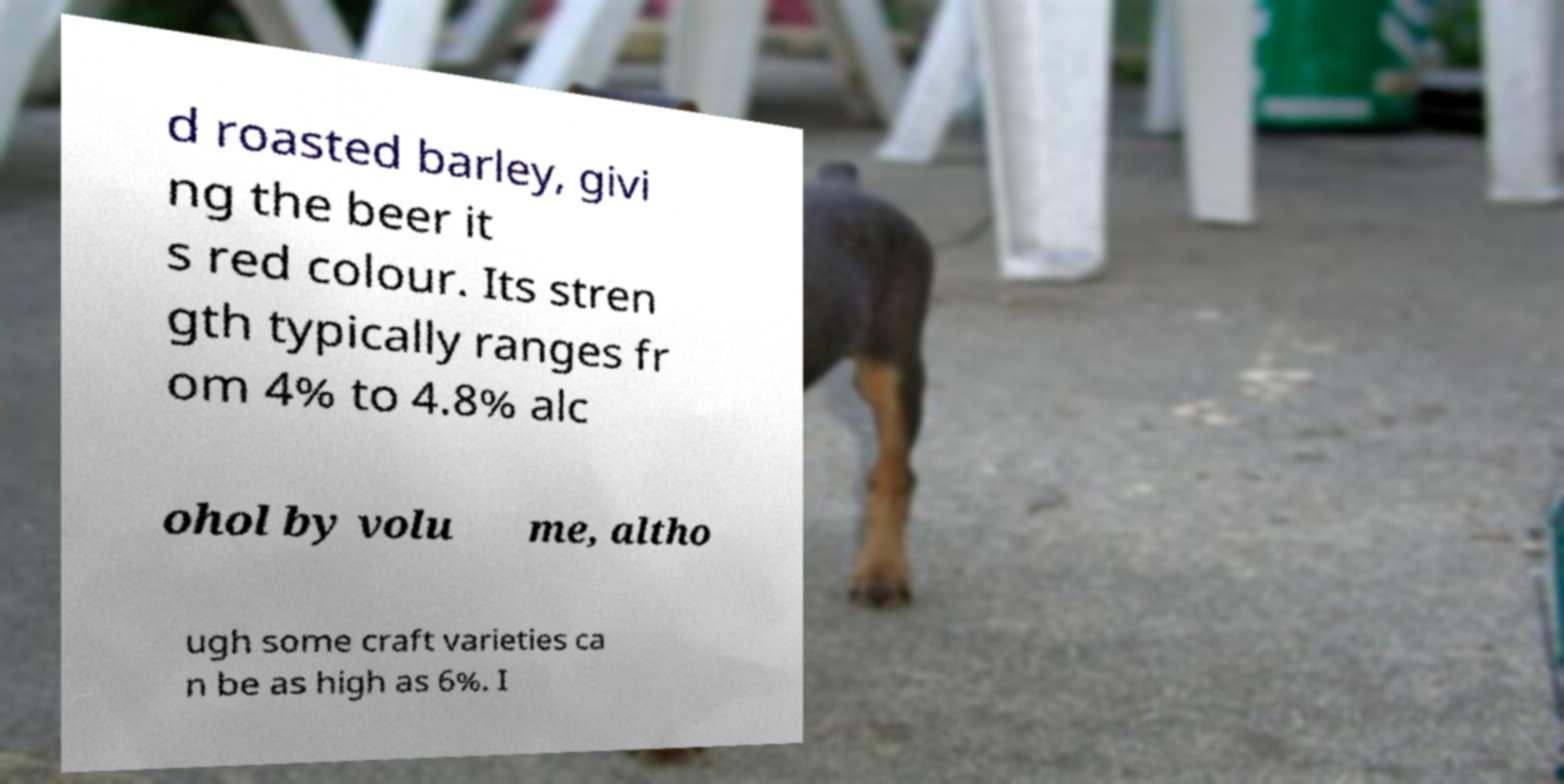Can you accurately transcribe the text from the provided image for me? d roasted barley, givi ng the beer it s red colour. Its stren gth typically ranges fr om 4% to 4.8% alc ohol by volu me, altho ugh some craft varieties ca n be as high as 6%. I 